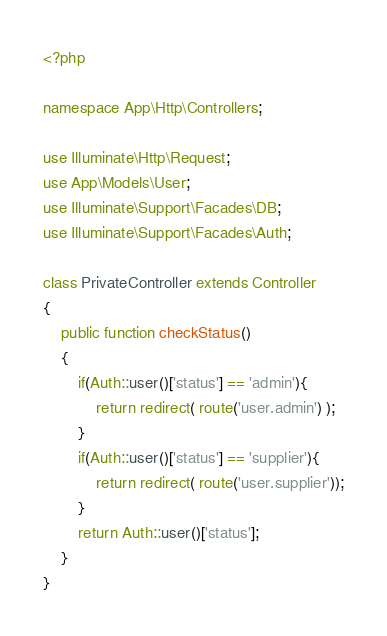Convert code to text. <code><loc_0><loc_0><loc_500><loc_500><_PHP_><?php

namespace App\Http\Controllers;

use Illuminate\Http\Request;
use App\Models\User;
use Illuminate\Support\Facades\DB;
use Illuminate\Support\Facades\Auth;

class PrivateController extends Controller
{
	public function checkStatus()
	{
		if(Auth::user()['status'] == 'admin'){
			return redirect( route('user.admin') );
		}
		if(Auth::user()['status'] == 'supplier'){
			return redirect( route('user.supplier'));
		}
		return Auth::user()['status'];
	}
}
</code> 